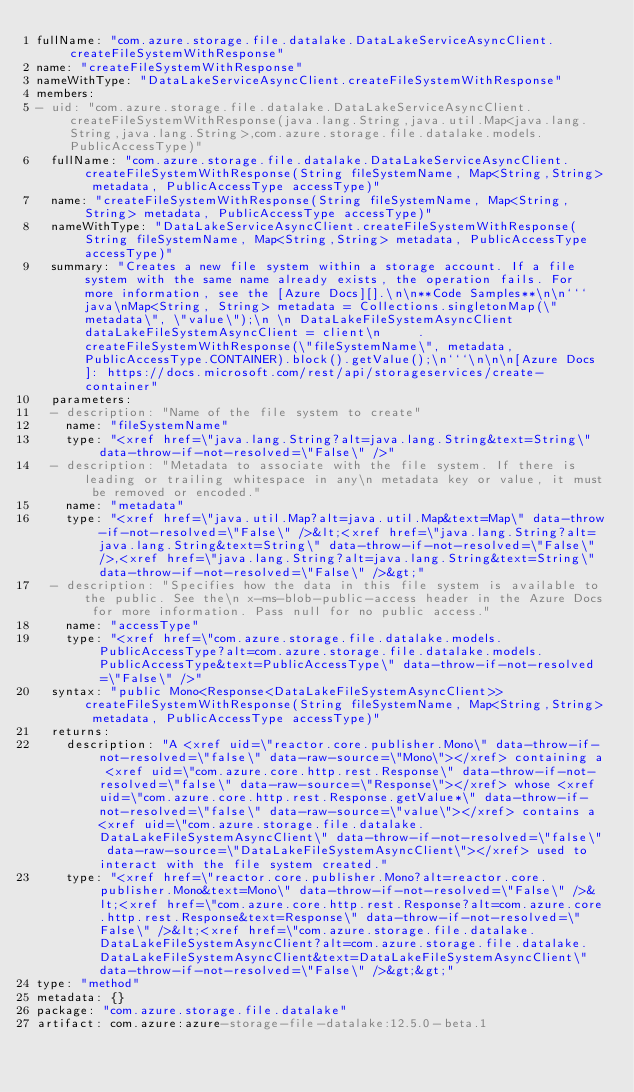Convert code to text. <code><loc_0><loc_0><loc_500><loc_500><_YAML_>fullName: "com.azure.storage.file.datalake.DataLakeServiceAsyncClient.createFileSystemWithResponse"
name: "createFileSystemWithResponse"
nameWithType: "DataLakeServiceAsyncClient.createFileSystemWithResponse"
members:
- uid: "com.azure.storage.file.datalake.DataLakeServiceAsyncClient.createFileSystemWithResponse(java.lang.String,java.util.Map<java.lang.String,java.lang.String>,com.azure.storage.file.datalake.models.PublicAccessType)"
  fullName: "com.azure.storage.file.datalake.DataLakeServiceAsyncClient.createFileSystemWithResponse(String fileSystemName, Map<String,String> metadata, PublicAccessType accessType)"
  name: "createFileSystemWithResponse(String fileSystemName, Map<String,String> metadata, PublicAccessType accessType)"
  nameWithType: "DataLakeServiceAsyncClient.createFileSystemWithResponse(String fileSystemName, Map<String,String> metadata, PublicAccessType accessType)"
  summary: "Creates a new file system within a storage account. If a file system with the same name already exists, the operation fails. For more information, see the [Azure Docs][].\n\n**Code Samples**\n\n```java\nMap<String, String> metadata = Collections.singletonMap(\"metadata\", \"value\");\n \n DataLakeFileSystemAsyncClient dataLakeFileSystemAsyncClient = client\n     .createFileSystemWithResponse(\"fileSystemName\", metadata, PublicAccessType.CONTAINER).block().getValue();\n```\n\n\n[Azure Docs]: https://docs.microsoft.com/rest/api/storageservices/create-container"
  parameters:
  - description: "Name of the file system to create"
    name: "fileSystemName"
    type: "<xref href=\"java.lang.String?alt=java.lang.String&text=String\" data-throw-if-not-resolved=\"False\" />"
  - description: "Metadata to associate with the file system. If there is leading or trailing whitespace in any\n metadata key or value, it must be removed or encoded."
    name: "metadata"
    type: "<xref href=\"java.util.Map?alt=java.util.Map&text=Map\" data-throw-if-not-resolved=\"False\" />&lt;<xref href=\"java.lang.String?alt=java.lang.String&text=String\" data-throw-if-not-resolved=\"False\" />,<xref href=\"java.lang.String?alt=java.lang.String&text=String\" data-throw-if-not-resolved=\"False\" />&gt;"
  - description: "Specifies how the data in this file system is available to the public. See the\n x-ms-blob-public-access header in the Azure Docs for more information. Pass null for no public access."
    name: "accessType"
    type: "<xref href=\"com.azure.storage.file.datalake.models.PublicAccessType?alt=com.azure.storage.file.datalake.models.PublicAccessType&text=PublicAccessType\" data-throw-if-not-resolved=\"False\" />"
  syntax: "public Mono<Response<DataLakeFileSystemAsyncClient>> createFileSystemWithResponse(String fileSystemName, Map<String,String> metadata, PublicAccessType accessType)"
  returns:
    description: "A <xref uid=\"reactor.core.publisher.Mono\" data-throw-if-not-resolved=\"false\" data-raw-source=\"Mono\"></xref> containing a <xref uid=\"com.azure.core.http.rest.Response\" data-throw-if-not-resolved=\"false\" data-raw-source=\"Response\"></xref> whose <xref uid=\"com.azure.core.http.rest.Response.getValue*\" data-throw-if-not-resolved=\"false\" data-raw-source=\"value\"></xref> contains a <xref uid=\"com.azure.storage.file.datalake.DataLakeFileSystemAsyncClient\" data-throw-if-not-resolved=\"false\" data-raw-source=\"DataLakeFileSystemAsyncClient\"></xref> used to interact with the file system created."
    type: "<xref href=\"reactor.core.publisher.Mono?alt=reactor.core.publisher.Mono&text=Mono\" data-throw-if-not-resolved=\"False\" />&lt;<xref href=\"com.azure.core.http.rest.Response?alt=com.azure.core.http.rest.Response&text=Response\" data-throw-if-not-resolved=\"False\" />&lt;<xref href=\"com.azure.storage.file.datalake.DataLakeFileSystemAsyncClient?alt=com.azure.storage.file.datalake.DataLakeFileSystemAsyncClient&text=DataLakeFileSystemAsyncClient\" data-throw-if-not-resolved=\"False\" />&gt;&gt;"
type: "method"
metadata: {}
package: "com.azure.storage.file.datalake"
artifact: com.azure:azure-storage-file-datalake:12.5.0-beta.1
</code> 